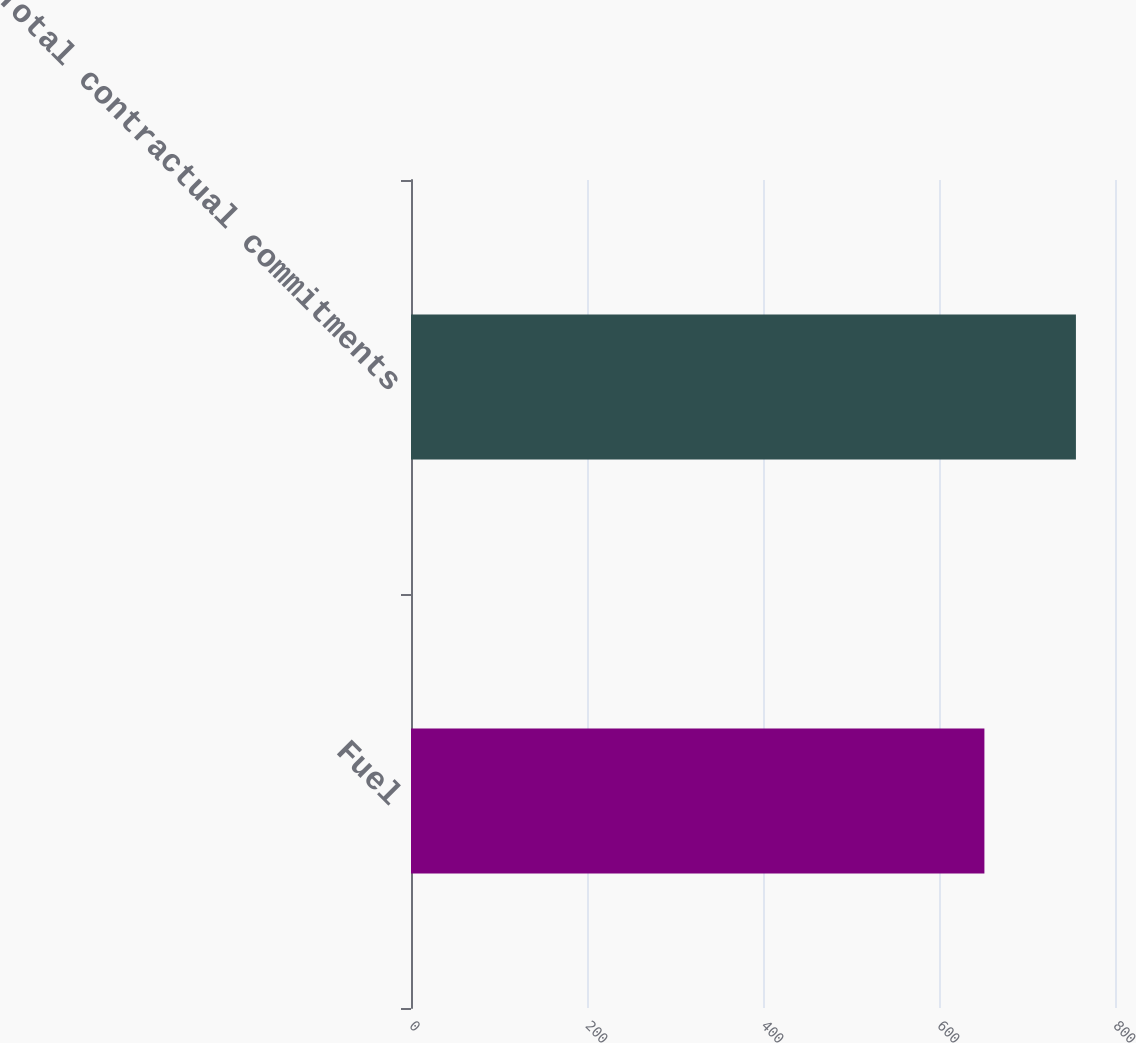Convert chart to OTSL. <chart><loc_0><loc_0><loc_500><loc_500><bar_chart><fcel>Fuel<fcel>Total contractual commitments<nl><fcel>651.6<fcel>755.6<nl></chart> 